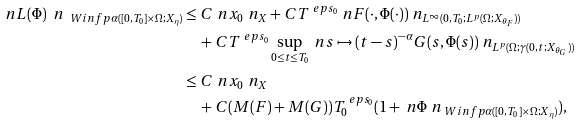Convert formula to latex. <formula><loc_0><loc_0><loc_500><loc_500>\ n L ( \Phi ) \ n _ { \ W i n f p { \alpha } ( [ 0 , T _ { 0 } ] \times \Omega ; X _ { \eta } ) } & \leq C \ n x _ { 0 } \ n _ { X } + C T ^ { \ e p s _ { 0 } } \ n F ( \cdot , \Phi ( \cdot ) ) \ n _ { L ^ { \infty } ( 0 , T _ { 0 } ; L ^ { p } ( \Omega ; X _ { \theta _ { F } } ) ) } \\ & \quad + C T ^ { \ e p s _ { 0 } } \sup _ { 0 \leq t \leq T _ { 0 } } \ n s \mapsto ( t - s ) ^ { - \alpha } G ( s , \Phi ( s ) ) \ n _ { L ^ { p } ( \Omega ; \gamma ( 0 , t ; X _ { \theta _ { G } } ) ) } \\ & \leq C \ n x _ { 0 } \ n _ { X } \\ & \quad + C ( M ( F ) + M ( G ) ) T _ { 0 } ^ { \ e p s _ { 0 } } ( 1 + \ n \Phi \ n _ { \ W i n f p { \alpha } ( [ 0 , T _ { 0 } ] \times \Omega ; X _ { \eta } ) } ) ,</formula> 